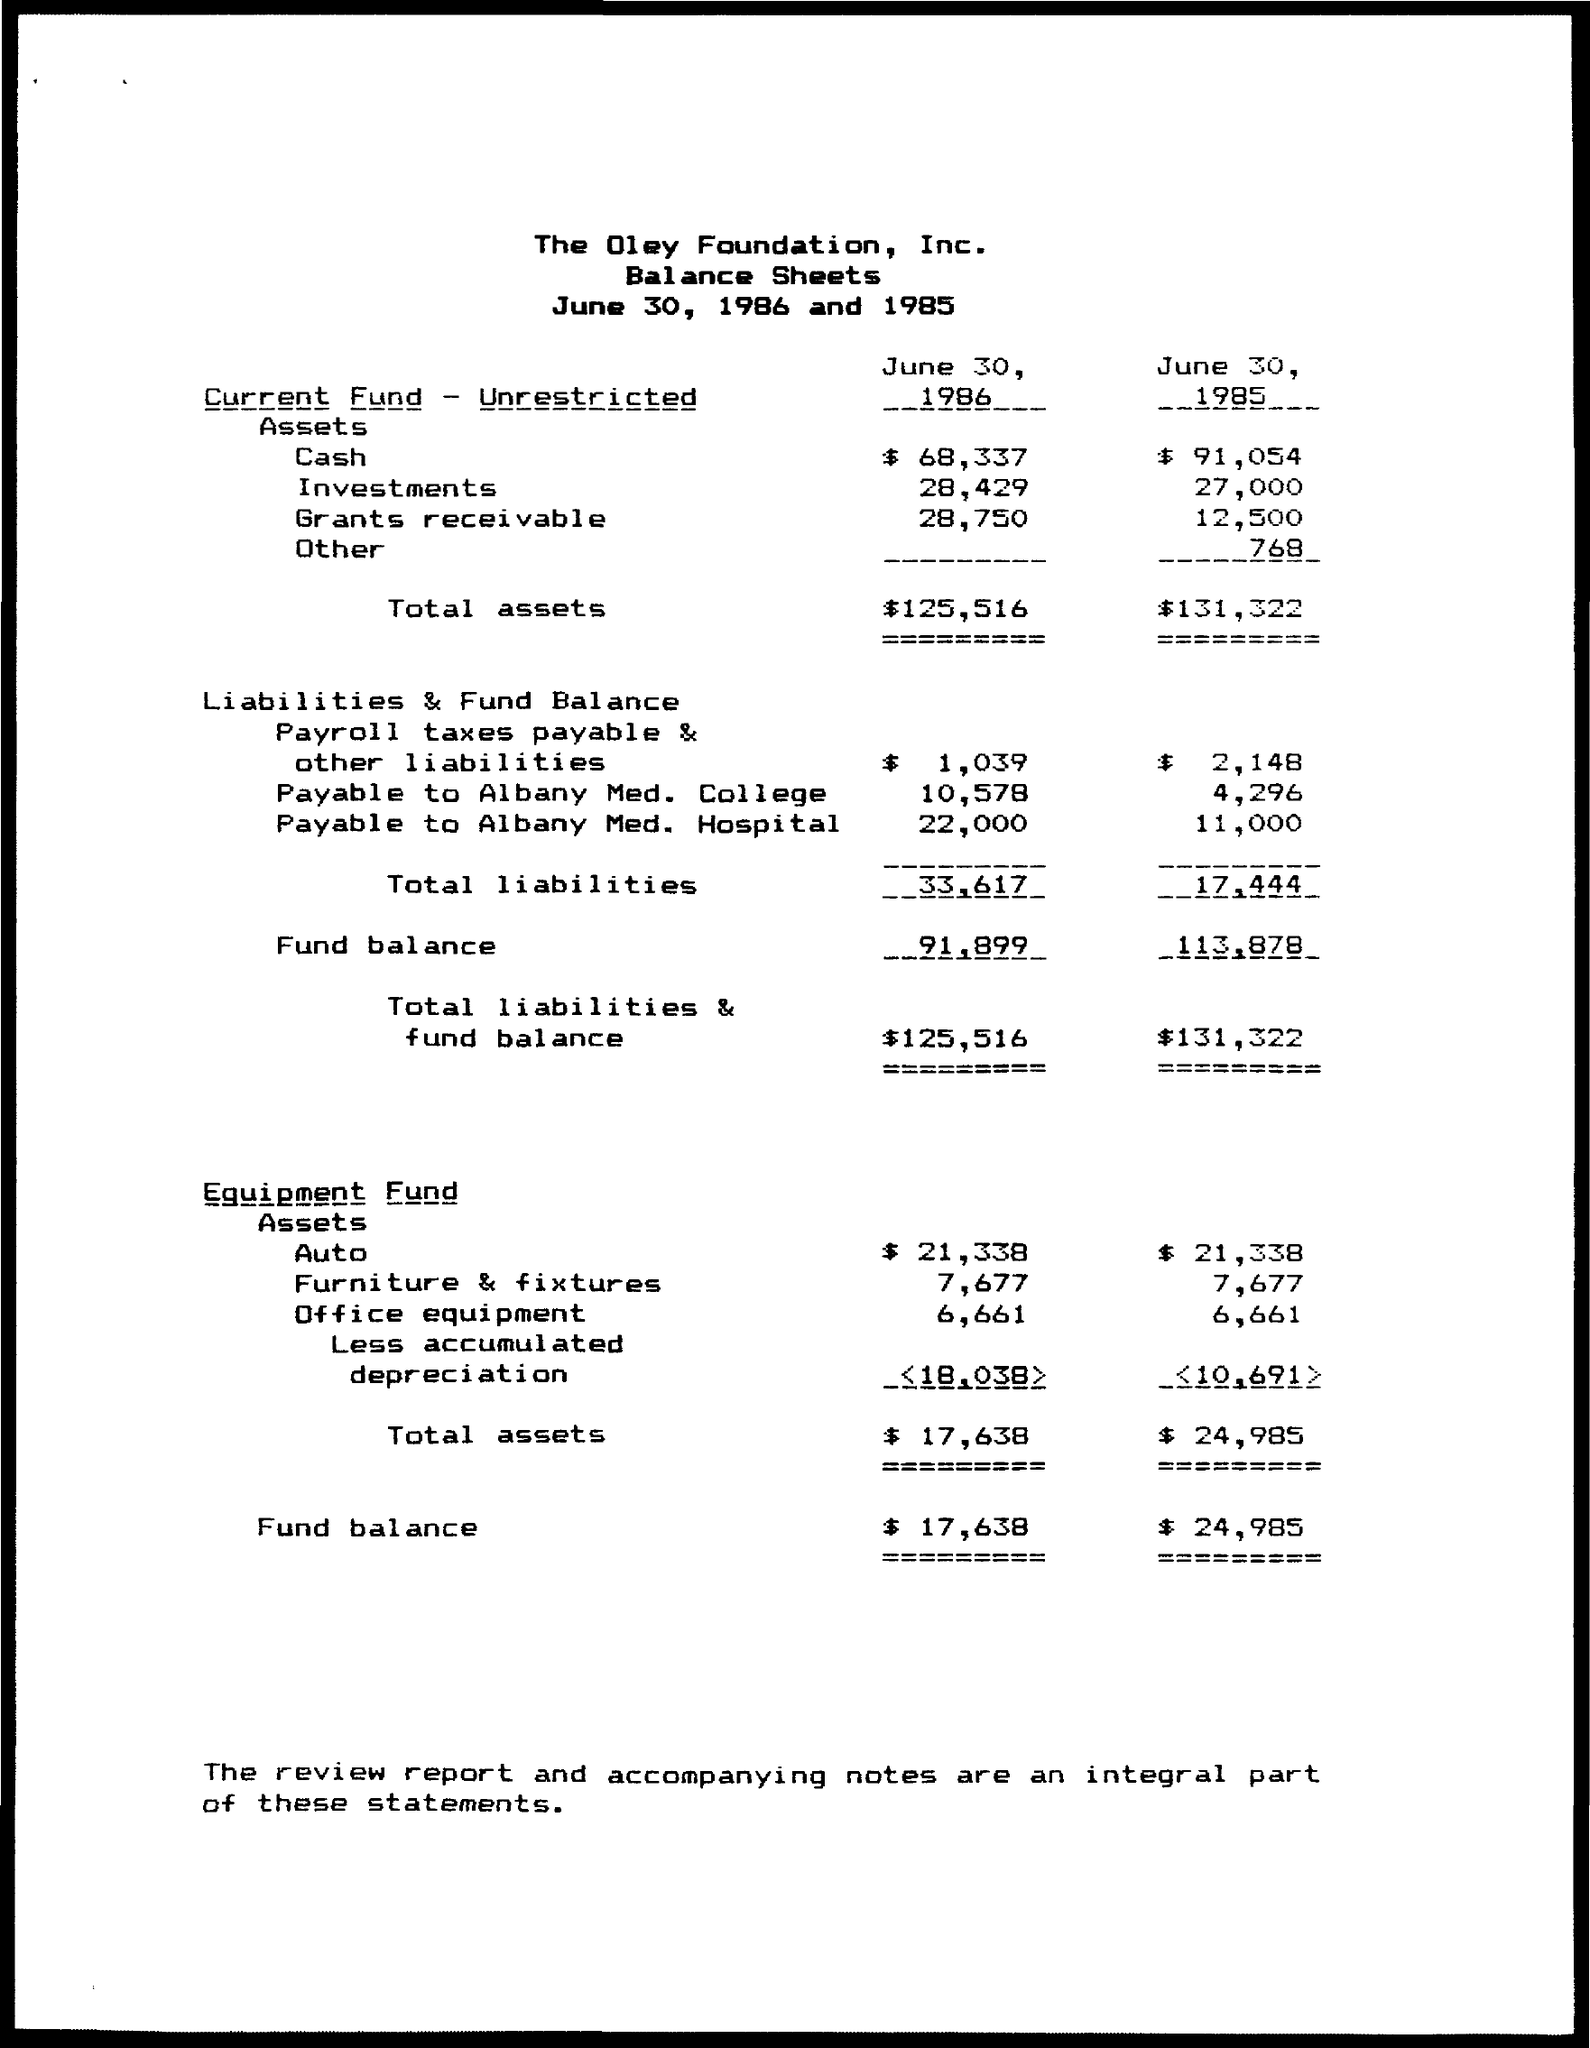List a handful of essential elements in this visual. On June 30, 1985, the total amount of liabilities was 17,444. The total assets on unrestricted current funds as of June 30, 1986, amounted to $125,516. The total assets on the equipment fund as of June 30, 1986, were 17,638. The balance sheet of a specific company is presented. The company is The Oley Foundation, Inc. On June 30, 1986, the total amount of liabilities and fund balance was $125,516. 